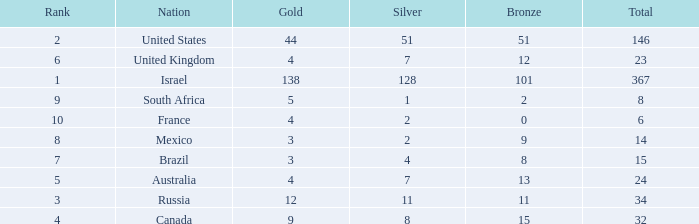What is the maximum number of silvers for a country with fewer than 12 golds and a total less than 8? 2.0. 